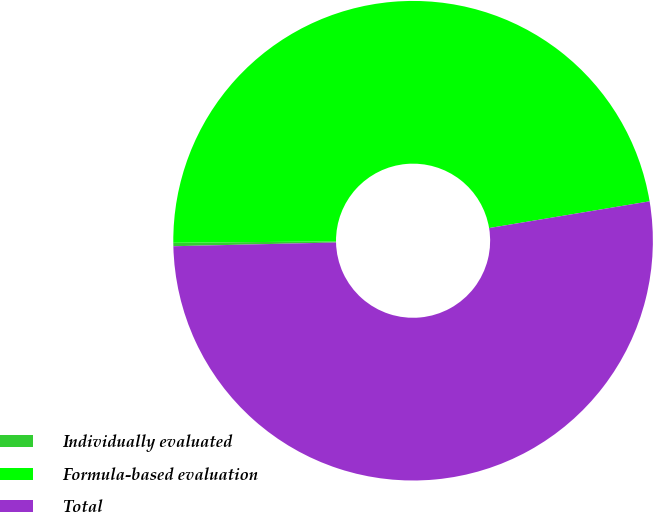Convert chart. <chart><loc_0><loc_0><loc_500><loc_500><pie_chart><fcel>Individually evaluated<fcel>Formula-based evaluation<fcel>Total<nl><fcel>0.23%<fcel>47.51%<fcel>52.26%<nl></chart> 